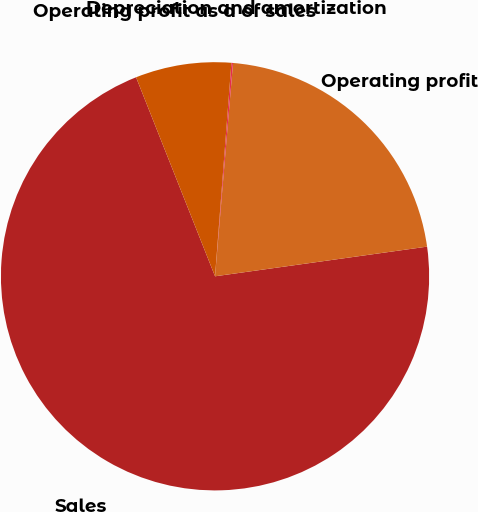Convert chart. <chart><loc_0><loc_0><loc_500><loc_500><pie_chart><fcel>Sales<fcel>Operating profit<fcel>Depreciation and amortization<fcel>Operating profit as a of sales<nl><fcel>71.2%<fcel>21.45%<fcel>0.12%<fcel>7.23%<nl></chart> 